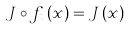<formula> <loc_0><loc_0><loc_500><loc_500>J \circ f _ { t } \left ( x \right ) = J \left ( x \right )</formula> 